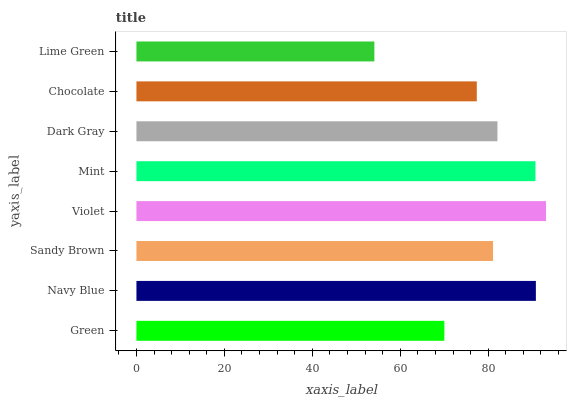Is Lime Green the minimum?
Answer yes or no. Yes. Is Violet the maximum?
Answer yes or no. Yes. Is Navy Blue the minimum?
Answer yes or no. No. Is Navy Blue the maximum?
Answer yes or no. No. Is Navy Blue greater than Green?
Answer yes or no. Yes. Is Green less than Navy Blue?
Answer yes or no. Yes. Is Green greater than Navy Blue?
Answer yes or no. No. Is Navy Blue less than Green?
Answer yes or no. No. Is Dark Gray the high median?
Answer yes or no. Yes. Is Sandy Brown the low median?
Answer yes or no. Yes. Is Chocolate the high median?
Answer yes or no. No. Is Mint the low median?
Answer yes or no. No. 